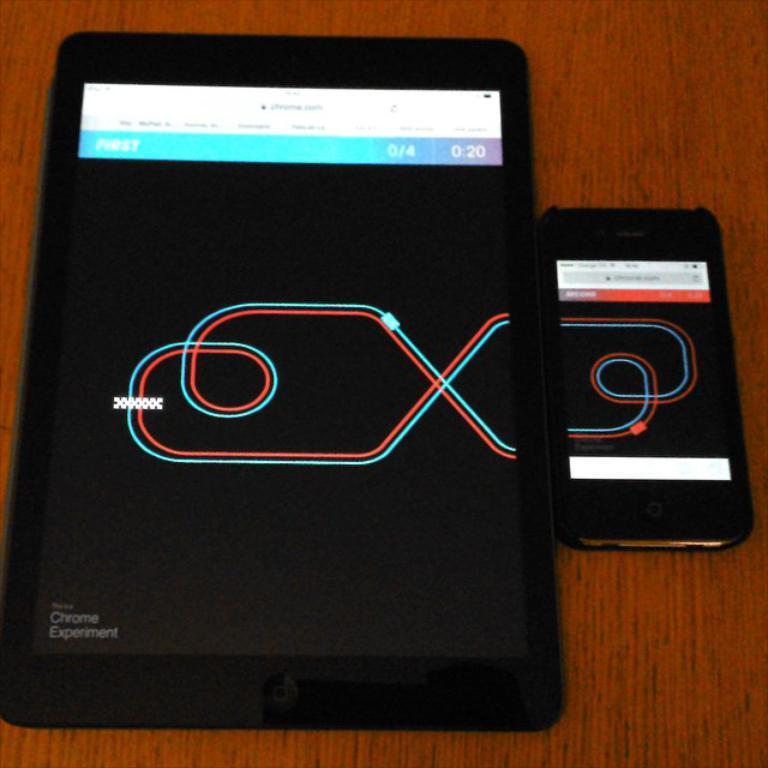What electronic devices can be seen in the image? There is a tablet and a mobile phone in the image. Where are the devices located? Both devices are present on a table. Is there any content displayed on the screens of the devices? Yes, there is a picture displayed on one of the screens. What is the representative doing with the giraffe in the image? There is no representative or giraffe present in the image. 